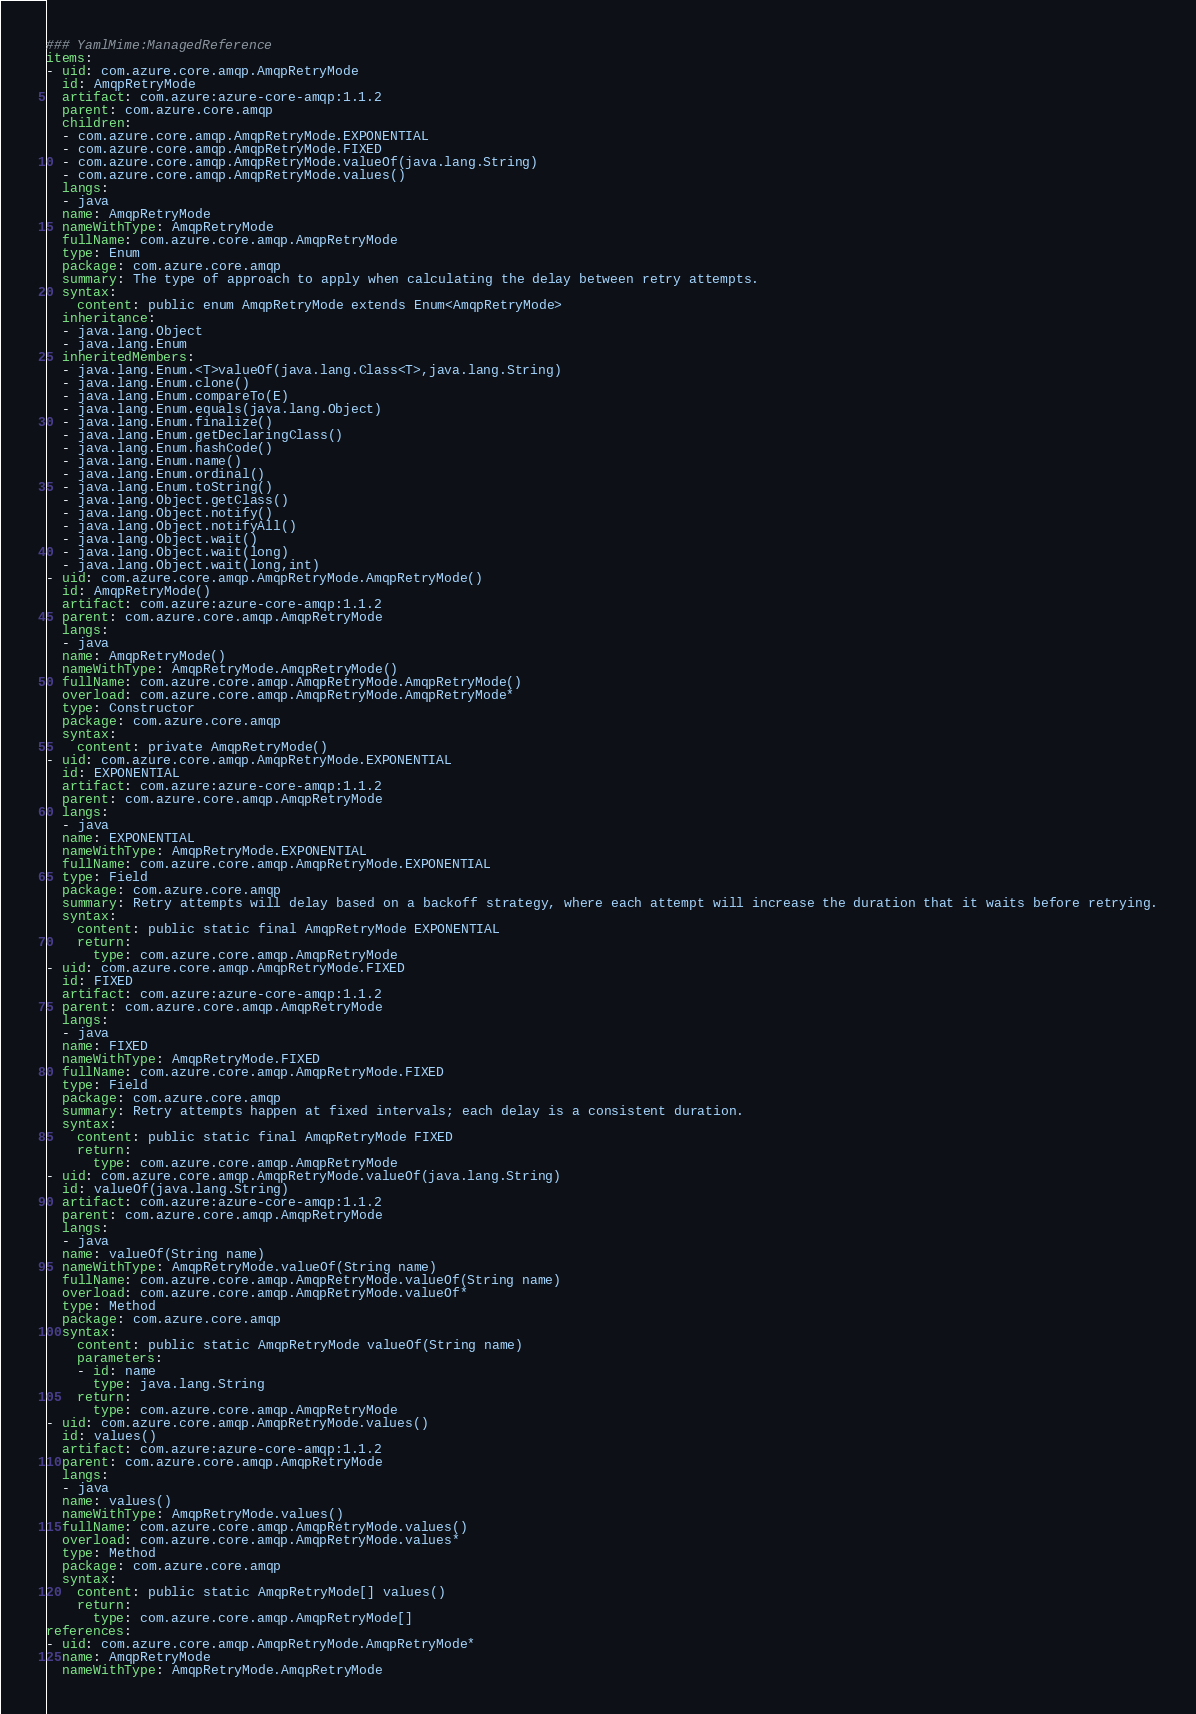<code> <loc_0><loc_0><loc_500><loc_500><_YAML_>### YamlMime:ManagedReference
items:
- uid: com.azure.core.amqp.AmqpRetryMode
  id: AmqpRetryMode
  artifact: com.azure:azure-core-amqp:1.1.2
  parent: com.azure.core.amqp
  children:
  - com.azure.core.amqp.AmqpRetryMode.EXPONENTIAL
  - com.azure.core.amqp.AmqpRetryMode.FIXED
  - com.azure.core.amqp.AmqpRetryMode.valueOf(java.lang.String)
  - com.azure.core.amqp.AmqpRetryMode.values()
  langs:
  - java
  name: AmqpRetryMode
  nameWithType: AmqpRetryMode
  fullName: com.azure.core.amqp.AmqpRetryMode
  type: Enum
  package: com.azure.core.amqp
  summary: The type of approach to apply when calculating the delay between retry attempts.
  syntax:
    content: public enum AmqpRetryMode extends Enum<AmqpRetryMode>
  inheritance:
  - java.lang.Object
  - java.lang.Enum
  inheritedMembers:
  - java.lang.Enum.<T>valueOf(java.lang.Class<T>,java.lang.String)
  - java.lang.Enum.clone()
  - java.lang.Enum.compareTo(E)
  - java.lang.Enum.equals(java.lang.Object)
  - java.lang.Enum.finalize()
  - java.lang.Enum.getDeclaringClass()
  - java.lang.Enum.hashCode()
  - java.lang.Enum.name()
  - java.lang.Enum.ordinal()
  - java.lang.Enum.toString()
  - java.lang.Object.getClass()
  - java.lang.Object.notify()
  - java.lang.Object.notifyAll()
  - java.lang.Object.wait()
  - java.lang.Object.wait(long)
  - java.lang.Object.wait(long,int)
- uid: com.azure.core.amqp.AmqpRetryMode.AmqpRetryMode()
  id: AmqpRetryMode()
  artifact: com.azure:azure-core-amqp:1.1.2
  parent: com.azure.core.amqp.AmqpRetryMode
  langs:
  - java
  name: AmqpRetryMode()
  nameWithType: AmqpRetryMode.AmqpRetryMode()
  fullName: com.azure.core.amqp.AmqpRetryMode.AmqpRetryMode()
  overload: com.azure.core.amqp.AmqpRetryMode.AmqpRetryMode*
  type: Constructor
  package: com.azure.core.amqp
  syntax:
    content: private AmqpRetryMode()
- uid: com.azure.core.amqp.AmqpRetryMode.EXPONENTIAL
  id: EXPONENTIAL
  artifact: com.azure:azure-core-amqp:1.1.2
  parent: com.azure.core.amqp.AmqpRetryMode
  langs:
  - java
  name: EXPONENTIAL
  nameWithType: AmqpRetryMode.EXPONENTIAL
  fullName: com.azure.core.amqp.AmqpRetryMode.EXPONENTIAL
  type: Field
  package: com.azure.core.amqp
  summary: Retry attempts will delay based on a backoff strategy, where each attempt will increase the duration that it waits before retrying.
  syntax:
    content: public static final AmqpRetryMode EXPONENTIAL
    return:
      type: com.azure.core.amqp.AmqpRetryMode
- uid: com.azure.core.amqp.AmqpRetryMode.FIXED
  id: FIXED
  artifact: com.azure:azure-core-amqp:1.1.2
  parent: com.azure.core.amqp.AmqpRetryMode
  langs:
  - java
  name: FIXED
  nameWithType: AmqpRetryMode.FIXED
  fullName: com.azure.core.amqp.AmqpRetryMode.FIXED
  type: Field
  package: com.azure.core.amqp
  summary: Retry attempts happen at fixed intervals; each delay is a consistent duration.
  syntax:
    content: public static final AmqpRetryMode FIXED
    return:
      type: com.azure.core.amqp.AmqpRetryMode
- uid: com.azure.core.amqp.AmqpRetryMode.valueOf(java.lang.String)
  id: valueOf(java.lang.String)
  artifact: com.azure:azure-core-amqp:1.1.2
  parent: com.azure.core.amqp.AmqpRetryMode
  langs:
  - java
  name: valueOf(String name)
  nameWithType: AmqpRetryMode.valueOf(String name)
  fullName: com.azure.core.amqp.AmqpRetryMode.valueOf(String name)
  overload: com.azure.core.amqp.AmqpRetryMode.valueOf*
  type: Method
  package: com.azure.core.amqp
  syntax:
    content: public static AmqpRetryMode valueOf(String name)
    parameters:
    - id: name
      type: java.lang.String
    return:
      type: com.azure.core.amqp.AmqpRetryMode
- uid: com.azure.core.amqp.AmqpRetryMode.values()
  id: values()
  artifact: com.azure:azure-core-amqp:1.1.2
  parent: com.azure.core.amqp.AmqpRetryMode
  langs:
  - java
  name: values()
  nameWithType: AmqpRetryMode.values()
  fullName: com.azure.core.amqp.AmqpRetryMode.values()
  overload: com.azure.core.amqp.AmqpRetryMode.values*
  type: Method
  package: com.azure.core.amqp
  syntax:
    content: public static AmqpRetryMode[] values()
    return:
      type: com.azure.core.amqp.AmqpRetryMode[]
references:
- uid: com.azure.core.amqp.AmqpRetryMode.AmqpRetryMode*
  name: AmqpRetryMode
  nameWithType: AmqpRetryMode.AmqpRetryMode</code> 